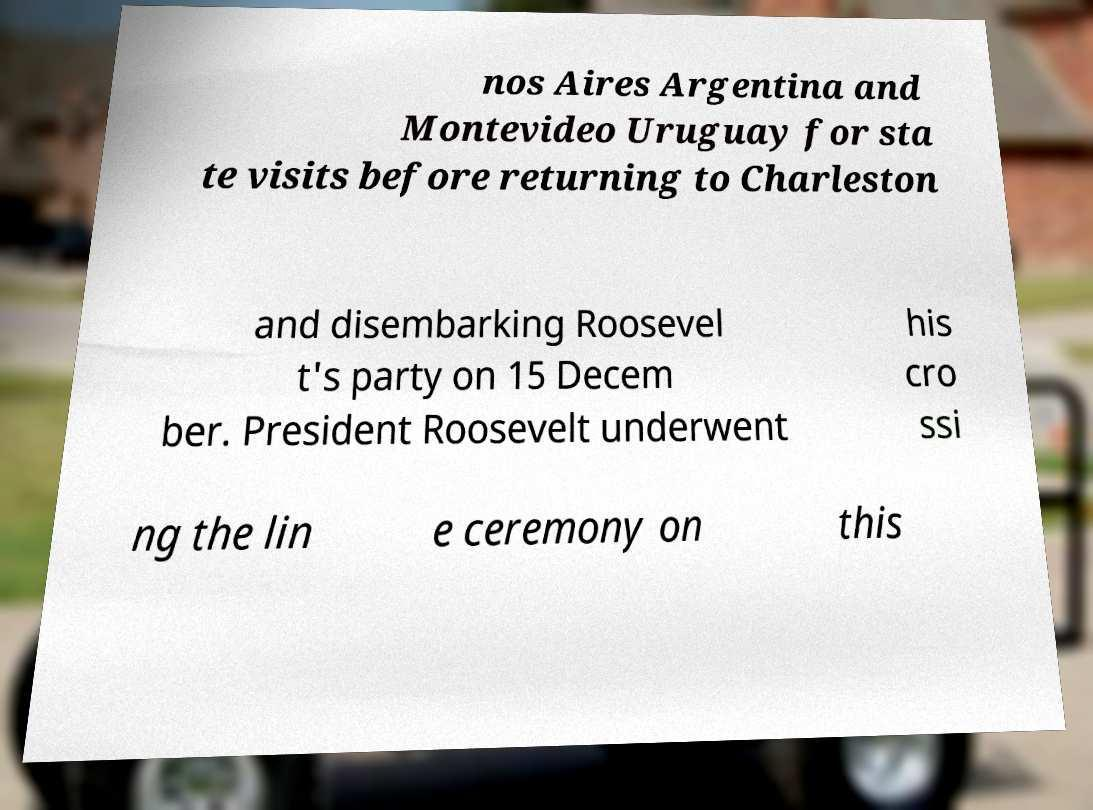What messages or text are displayed in this image? I need them in a readable, typed format. nos Aires Argentina and Montevideo Uruguay for sta te visits before returning to Charleston and disembarking Roosevel t's party on 15 Decem ber. President Roosevelt underwent his cro ssi ng the lin e ceremony on this 